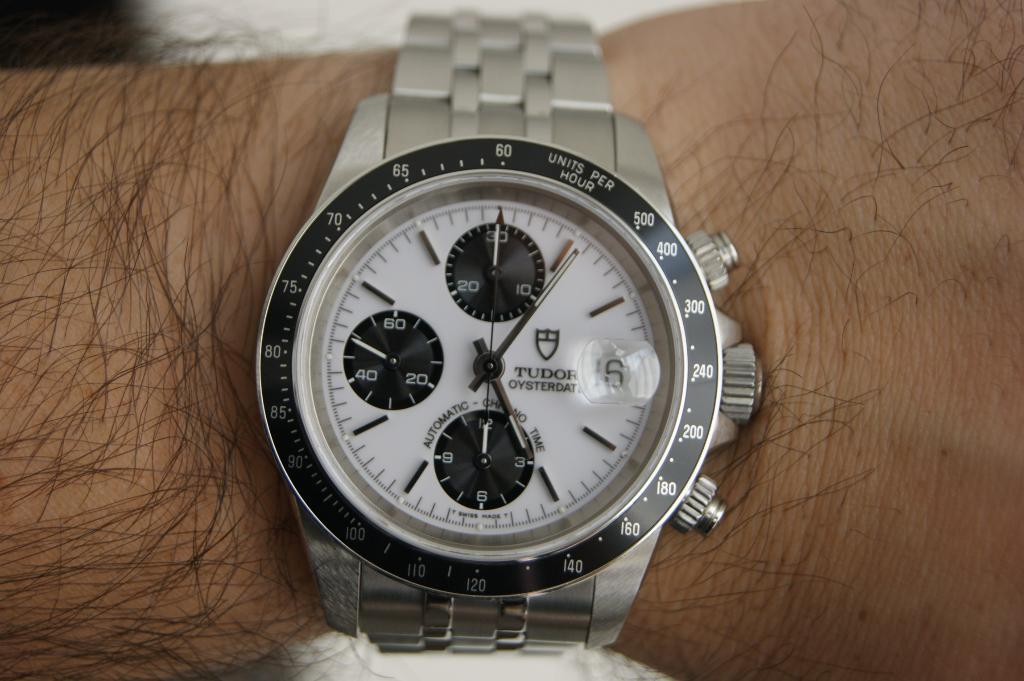<image>
Render a clear and concise summary of the photo. A man is wearing a TUDOR OYSTERDATE watch on his wrist. 